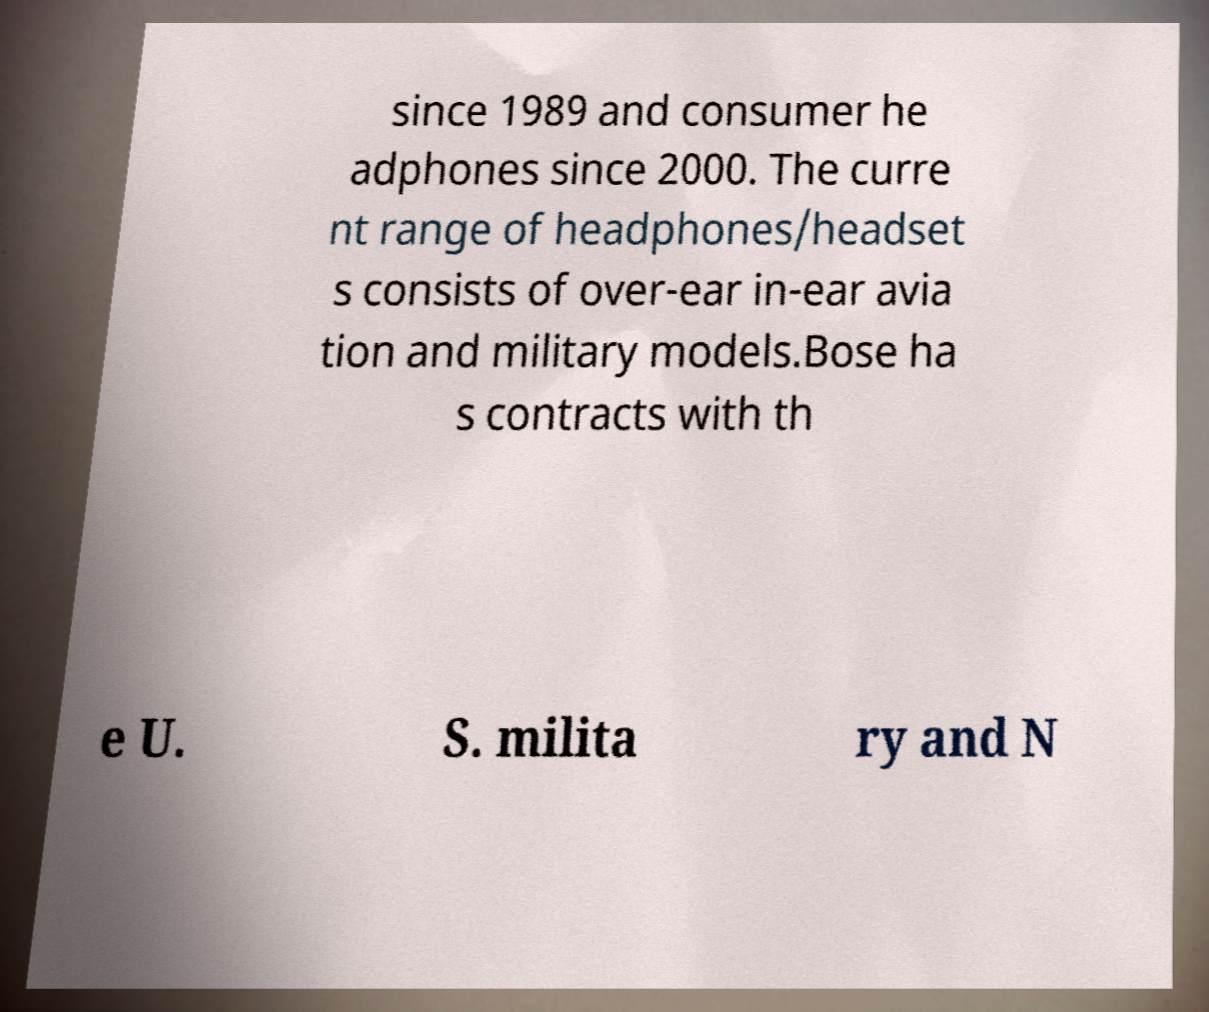Can you read and provide the text displayed in the image?This photo seems to have some interesting text. Can you extract and type it out for me? since 1989 and consumer he adphones since 2000. The curre nt range of headphones/headset s consists of over-ear in-ear avia tion and military models.Bose ha s contracts with th e U. S. milita ry and N 